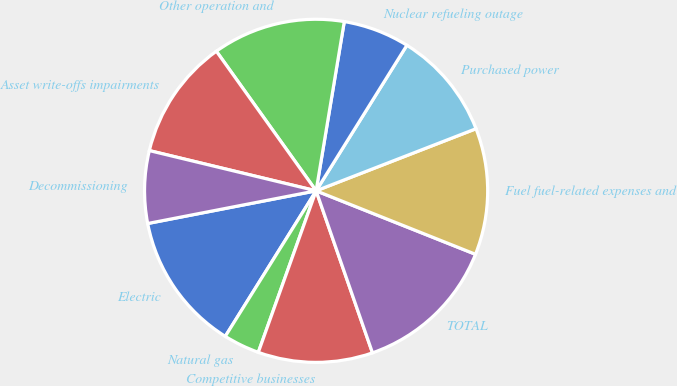Convert chart to OTSL. <chart><loc_0><loc_0><loc_500><loc_500><pie_chart><fcel>Electric<fcel>Natural gas<fcel>Competitive businesses<fcel>TOTAL<fcel>Fuel fuel-related expenses and<fcel>Purchased power<fcel>Nuclear refueling outage<fcel>Other operation and<fcel>Asset write-offs impairments<fcel>Decommissioning<nl><fcel>13.07%<fcel>3.41%<fcel>10.8%<fcel>13.64%<fcel>11.93%<fcel>10.23%<fcel>6.25%<fcel>12.5%<fcel>11.36%<fcel>6.82%<nl></chart> 